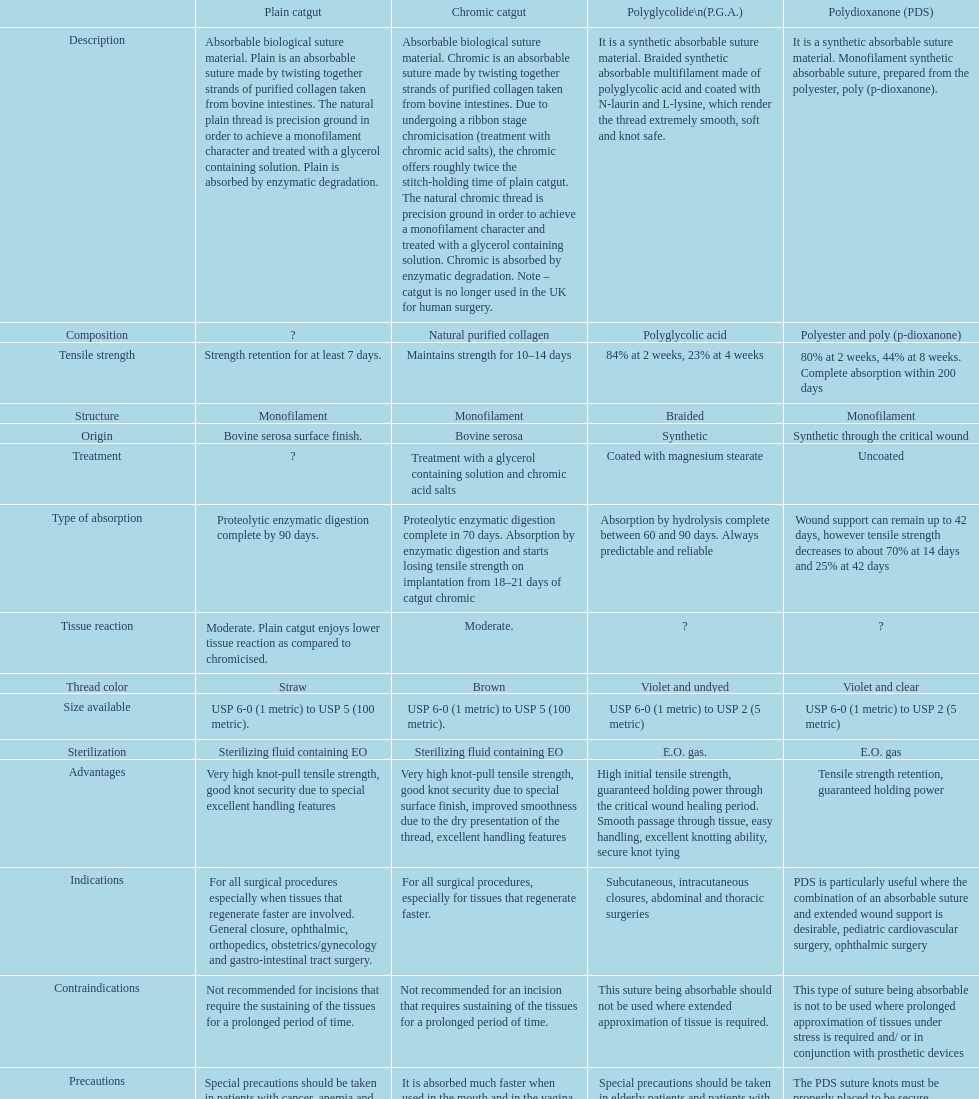What is the arrangement other than monofilament? Braided. 